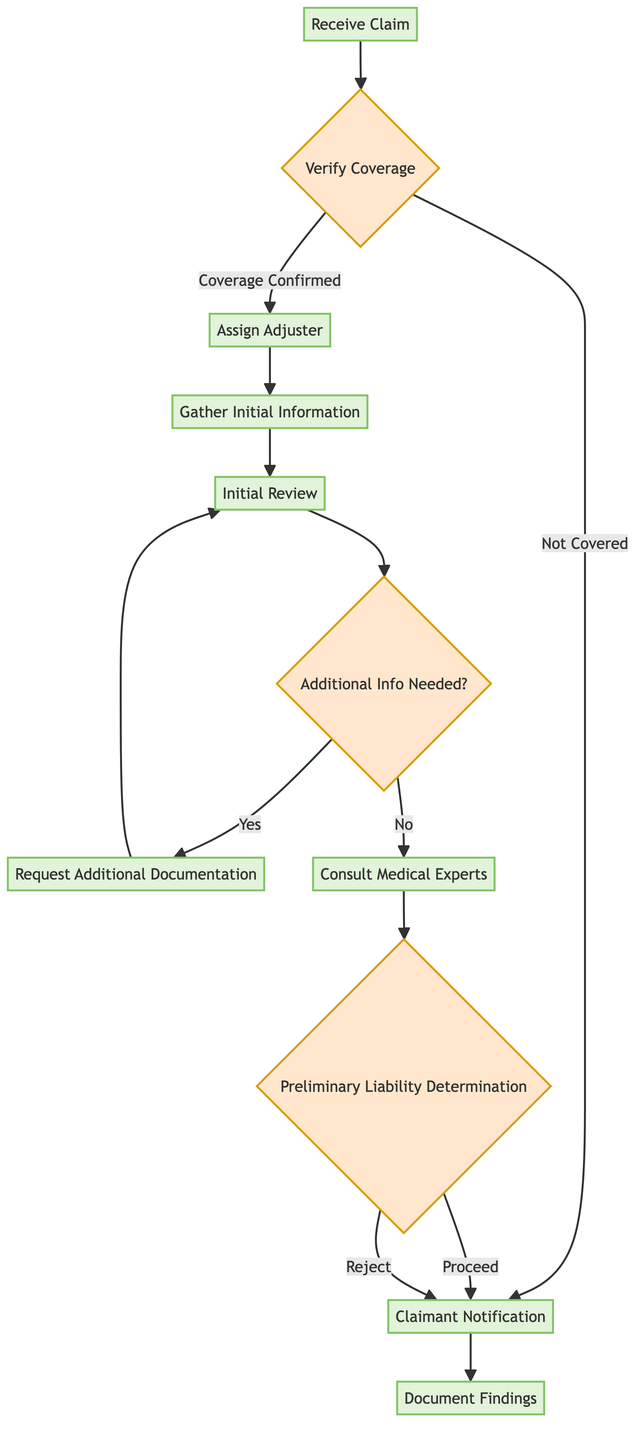What is the first step in the claim intake process? The diagram starts with "Receive Claim," which indicates that the first step is to receive the malpractice claim from the claimant.
Answer: Receive Claim How many decision points are there in the diagram? The diagram contains three decision points: "Verify Coverage," "Additional Info Needed?" and "Preliminary Liability Determination." Counting these gives a total of three decision points.
Answer: 3 What happens if the coverage is not confirmed? According to the flowchart, if coverage is not confirmed at the "Verify Coverage" decision point, the next step is to notify the claimant.
Answer: Claimant Notification What is the last action taken in the process? The final action shown in the diagram is "Document Findings," which is executed after notifying the claimant about the decision.
Answer: Document Findings What step follows after the "Initial Review"? After the "Initial Review," there is a decision, "Additional Info Needed?" which dictates whether to request more documentation or consult medical experts.
Answer: Additional Info Needed? Which step involves engaging medical professionals? The step where medical professionals are engaged to review the claim is labeled "Consult Medical Experts." This follows after the "Initial Review" if no additional information is needed.
Answer: Consult Medical Experts If the preliminary liability determination is to proceed, what is the next step? Once the preliminary liability determination indicates to proceed, the next step is to notify the claimant.
Answer: Claimant Notification List the actions in sequence after "Assign Adjuster." Following "Assign Adjuster," the sequence of actions is "Gather Initial Information," then "Initial Review," followed by a decision regarding "Additional Info Needed?"
Answer: Gather Initial Information, Initial Review, Additional Info Needed? 